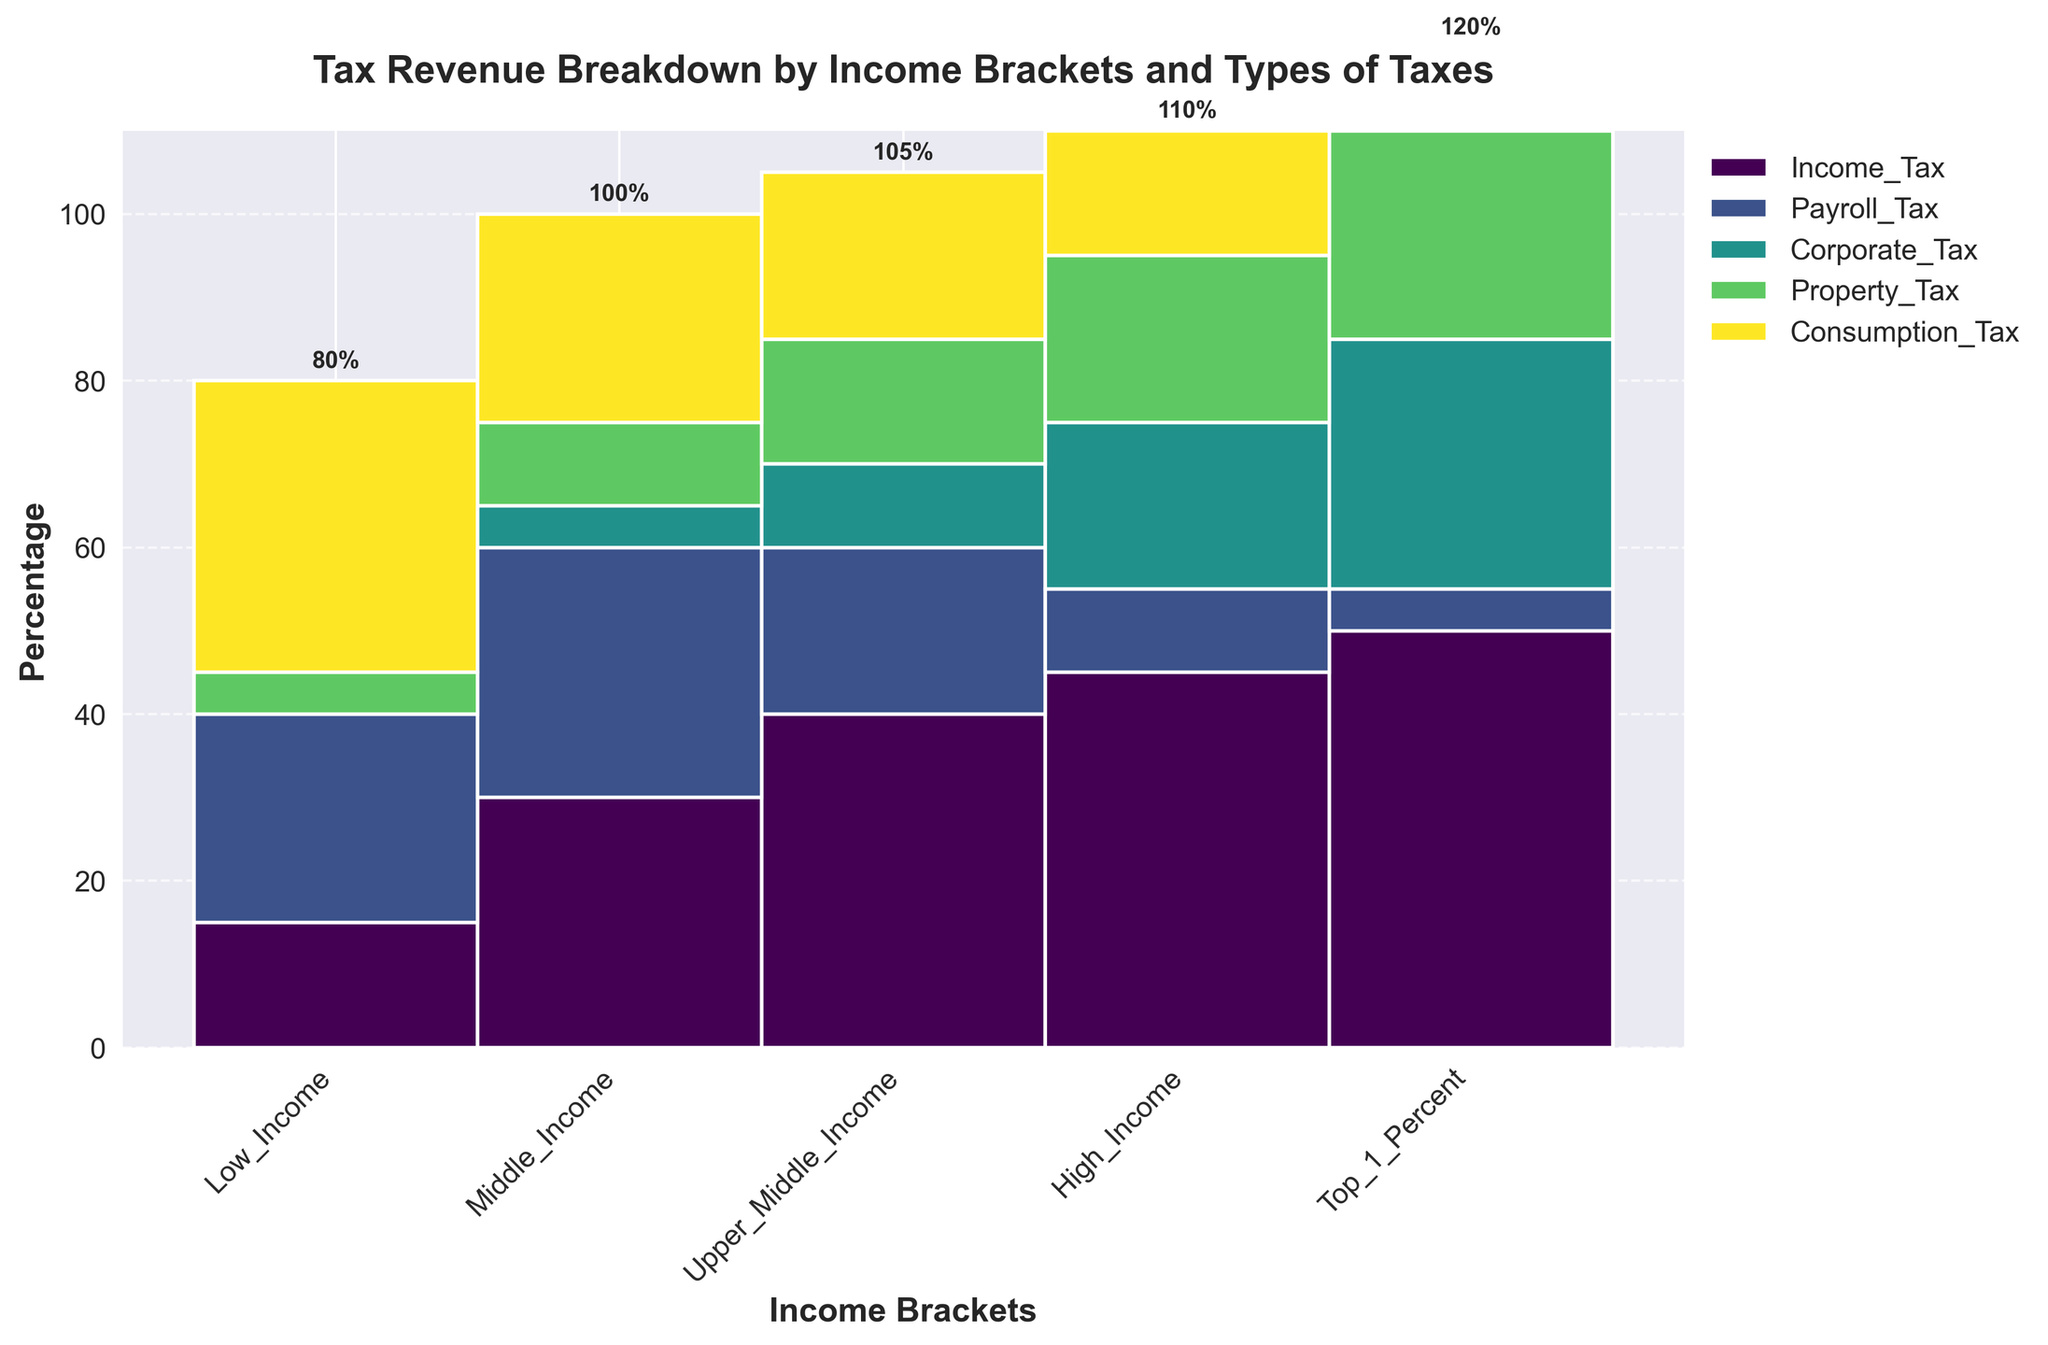What is the title of the plot? The title of the plot can be found at the top of the figure. Reading the text at the top reveals the title.
Answer: Tax Revenue Breakdown by Income Brackets and Types of Taxes What percentage of tax revenue does the High_Income bracket contribute to Income Tax? To find this information, look at the bar representing the High_Income bracket and the segment labeled 'Income_Tax'. The value corresponding to this segment will provide the percentage.
Answer: 45% Which income bracket contributes the highest percentage to Payroll Tax? Compare the Payroll Tax segments across all income brackets. The highest value segment indicates the income bracket with the highest contribution.
Answer: Middle_Income What is the total percentage contribution of Corporate Tax for the Top_1_Percent bracket? Look at the Corporate Tax segment in the Top_1_Percent bracket and read the percentage indicated by this segment.
Answer: 30% Which type of tax has the smallest contribution as a percentage in the Low_Income bracket? Examine the segments of the Low_Income bracket and identify which segment has the smallest value.
Answer: Corporate_Tax How does the contribution of Consumption Tax vary from Low_Income to Top_1_Percent? Analyze the height of the Consumption Tax segments across the income brackets starting from Low_Income to Top_1_Percent and note the changes.
Answer: Decreases What is the combined total percentage of Income Tax and Payroll Tax for the Upper_Middle_Income bracket? Calculate the sum of the Income Tax and Payroll Tax percentages for Upper_Middle_Income by adding their values: 40 + 20.
Answer: 60% Which income bracket has the highest overall tax contribution, and what is the percentage? Determine the bracket with the tallest bar by comparing the total heights of the bars across all brackets.
Answer: Top_1_Percent, 120% Is there any tax type for which the contribution percentage decreases consistently across all income brackets from Low to Top_1_Percent? Examine each tax type and see if any type shows a consistent decrease in percentage from Low_Income to Top_1_Percent.
Answer: Payroll_Tax Which income bracket has a higher total tax contribution: Middle_Income or Upper_Middle_Income? Sum the total percentages of all tax types for both Middle_Income and Upper_Middle_Income. Compare the sums to determine which is larger: Middle_Income (100) vs. Upper_Middle_Income (105).
Answer: Upper_Middle_Income 